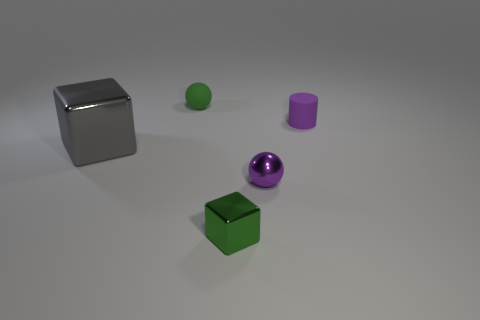Is there any other thing that is the same size as the gray thing?
Your answer should be very brief. No. What is the size of the metallic cube that is behind the small green object in front of the gray metallic block?
Give a very brief answer. Large. How many shiny balls have the same color as the cylinder?
Give a very brief answer. 1. How many things are there?
Offer a terse response. 5. What number of blue cylinders have the same material as the tiny green sphere?
Ensure brevity in your answer.  0. What is the size of the gray shiny thing that is the same shape as the tiny green metal thing?
Provide a short and direct response. Large. What is the material of the small green sphere?
Offer a very short reply. Rubber. There is a tiny sphere behind the shiny thing that is behind the ball that is to the right of the green cube; what is it made of?
Your answer should be compact. Rubber. Is there anything else that is the same shape as the tiny purple shiny thing?
Offer a terse response. Yes. What is the color of the tiny object that is the same shape as the large object?
Ensure brevity in your answer.  Green. 